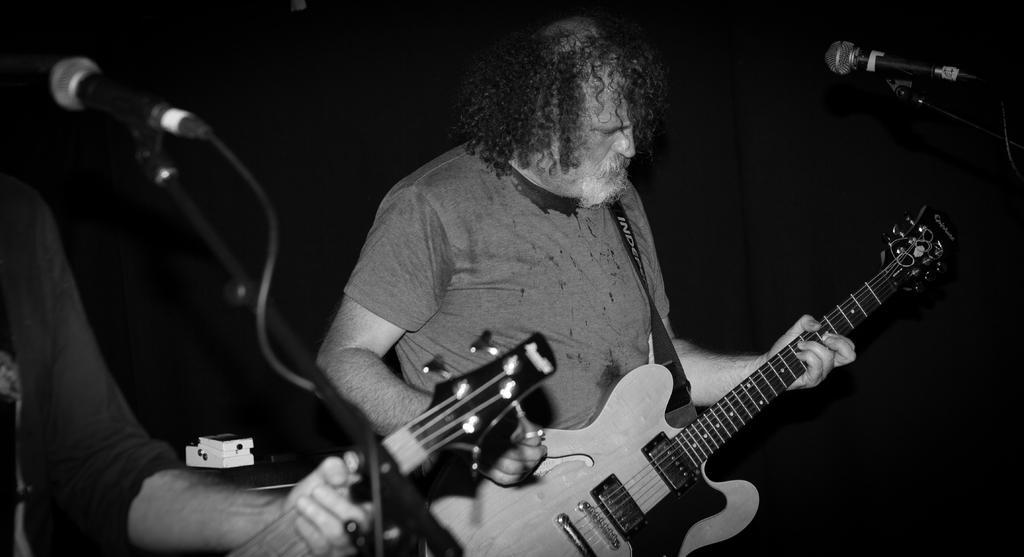Please provide a concise description of this image. A man is standing also holding a guitar. It's a microphone. 